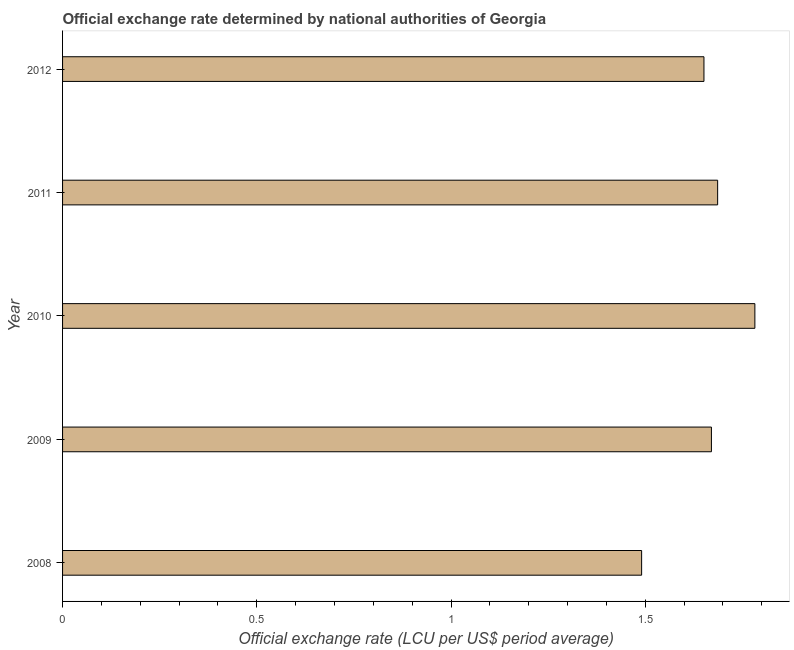What is the title of the graph?
Give a very brief answer. Official exchange rate determined by national authorities of Georgia. What is the label or title of the X-axis?
Offer a terse response. Official exchange rate (LCU per US$ period average). What is the label or title of the Y-axis?
Give a very brief answer. Year. What is the official exchange rate in 2009?
Ensure brevity in your answer.  1.67. Across all years, what is the maximum official exchange rate?
Make the answer very short. 1.78. Across all years, what is the minimum official exchange rate?
Provide a short and direct response. 1.49. In which year was the official exchange rate maximum?
Your response must be concise. 2010. In which year was the official exchange rate minimum?
Your answer should be compact. 2008. What is the sum of the official exchange rate?
Make the answer very short. 8.28. What is the difference between the official exchange rate in 2008 and 2009?
Offer a very short reply. -0.18. What is the average official exchange rate per year?
Give a very brief answer. 1.66. What is the median official exchange rate?
Offer a very short reply. 1.67. In how many years, is the official exchange rate greater than 0.4 ?
Provide a succinct answer. 5. Do a majority of the years between 2011 and 2010 (inclusive) have official exchange rate greater than 0.2 ?
Provide a succinct answer. No. What is the ratio of the official exchange rate in 2008 to that in 2011?
Ensure brevity in your answer.  0.88. Is the official exchange rate in 2008 less than that in 2010?
Make the answer very short. Yes. What is the difference between the highest and the second highest official exchange rate?
Give a very brief answer. 0.1. Is the sum of the official exchange rate in 2009 and 2012 greater than the maximum official exchange rate across all years?
Make the answer very short. Yes. What is the difference between the highest and the lowest official exchange rate?
Provide a short and direct response. 0.29. How many bars are there?
Your response must be concise. 5. What is the difference between two consecutive major ticks on the X-axis?
Give a very brief answer. 0.5. Are the values on the major ticks of X-axis written in scientific E-notation?
Make the answer very short. No. What is the Official exchange rate (LCU per US$ period average) of 2008?
Make the answer very short. 1.49. What is the Official exchange rate (LCU per US$ period average) of 2009?
Keep it short and to the point. 1.67. What is the Official exchange rate (LCU per US$ period average) of 2010?
Your answer should be very brief. 1.78. What is the Official exchange rate (LCU per US$ period average) of 2011?
Make the answer very short. 1.69. What is the Official exchange rate (LCU per US$ period average) of 2012?
Keep it short and to the point. 1.65. What is the difference between the Official exchange rate (LCU per US$ period average) in 2008 and 2009?
Offer a terse response. -0.18. What is the difference between the Official exchange rate (LCU per US$ period average) in 2008 and 2010?
Your response must be concise. -0.29. What is the difference between the Official exchange rate (LCU per US$ period average) in 2008 and 2011?
Your response must be concise. -0.2. What is the difference between the Official exchange rate (LCU per US$ period average) in 2008 and 2012?
Provide a short and direct response. -0.16. What is the difference between the Official exchange rate (LCU per US$ period average) in 2009 and 2010?
Offer a very short reply. -0.11. What is the difference between the Official exchange rate (LCU per US$ period average) in 2009 and 2011?
Provide a short and direct response. -0.02. What is the difference between the Official exchange rate (LCU per US$ period average) in 2009 and 2012?
Provide a succinct answer. 0.02. What is the difference between the Official exchange rate (LCU per US$ period average) in 2010 and 2011?
Keep it short and to the point. 0.1. What is the difference between the Official exchange rate (LCU per US$ period average) in 2010 and 2012?
Your response must be concise. 0.13. What is the difference between the Official exchange rate (LCU per US$ period average) in 2011 and 2012?
Your answer should be compact. 0.04. What is the ratio of the Official exchange rate (LCU per US$ period average) in 2008 to that in 2009?
Your answer should be very brief. 0.89. What is the ratio of the Official exchange rate (LCU per US$ period average) in 2008 to that in 2010?
Make the answer very short. 0.84. What is the ratio of the Official exchange rate (LCU per US$ period average) in 2008 to that in 2011?
Ensure brevity in your answer.  0.88. What is the ratio of the Official exchange rate (LCU per US$ period average) in 2008 to that in 2012?
Give a very brief answer. 0.9. What is the ratio of the Official exchange rate (LCU per US$ period average) in 2009 to that in 2010?
Offer a terse response. 0.94. What is the ratio of the Official exchange rate (LCU per US$ period average) in 2010 to that in 2011?
Give a very brief answer. 1.06. What is the ratio of the Official exchange rate (LCU per US$ period average) in 2010 to that in 2012?
Give a very brief answer. 1.08. 